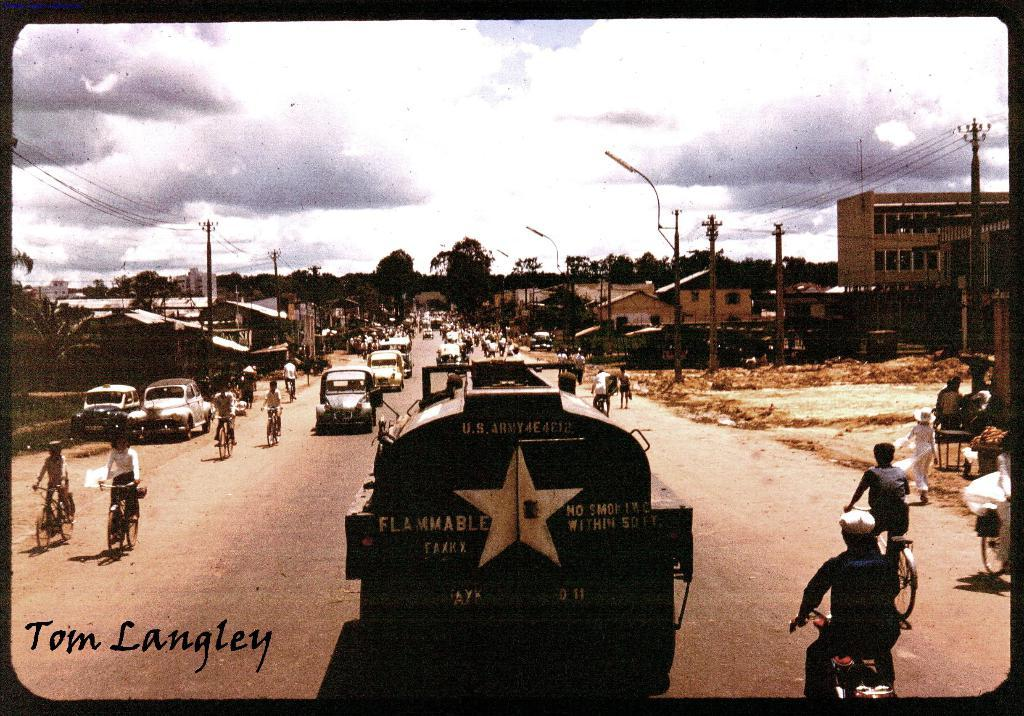<image>
Share a concise interpretation of the image provided. Large vehicle containing flammable material is riding down a busy street full of cars on either side of the street and also pedestrians on foot and bicycles. 